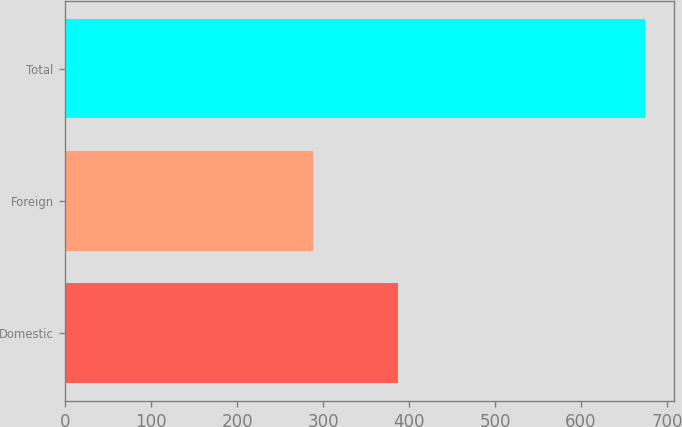Convert chart. <chart><loc_0><loc_0><loc_500><loc_500><bar_chart><fcel>Domestic<fcel>Foreign<fcel>Total<nl><fcel>386.9<fcel>287.9<fcel>674.8<nl></chart> 